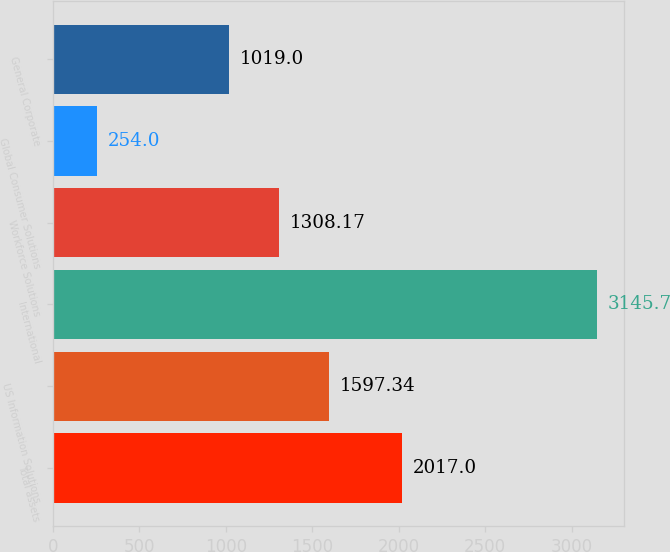Convert chart to OTSL. <chart><loc_0><loc_0><loc_500><loc_500><bar_chart><fcel>Total assets<fcel>US Information Solutions<fcel>International<fcel>Workforce Solutions<fcel>Global Consumer Solutions<fcel>General Corporate<nl><fcel>2017<fcel>1597.34<fcel>3145.7<fcel>1308.17<fcel>254<fcel>1019<nl></chart> 